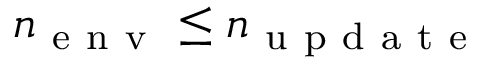<formula> <loc_0><loc_0><loc_500><loc_500>n _ { e n v } \leq n _ { u p d a t e }</formula> 